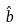Convert formula to latex. <formula><loc_0><loc_0><loc_500><loc_500>\hat { b }</formula> 